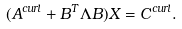<formula> <loc_0><loc_0><loc_500><loc_500>( A ^ { c u r l } + B ^ { T } \Lambda B ) X = C ^ { c u r l } .</formula> 